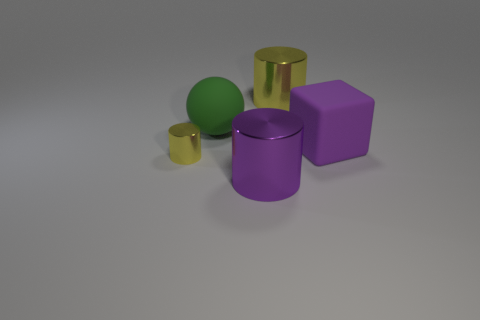Could you describe the shapes present in the image? Certainly, the image features a variety of simple geometric shapes. There are two cylinders, one tall and one short, a cube, and a sphere. These shapes are often used in visual and artistic studies to demonstrate perspective, shading, and composition.  How many objects in the image appear to have a metallic texture? There are three objects in the image that have a metallic texture. The tall and short cylinders, as well as the cube, display shiny, reflective surfaces characteristic of metallic textures. 